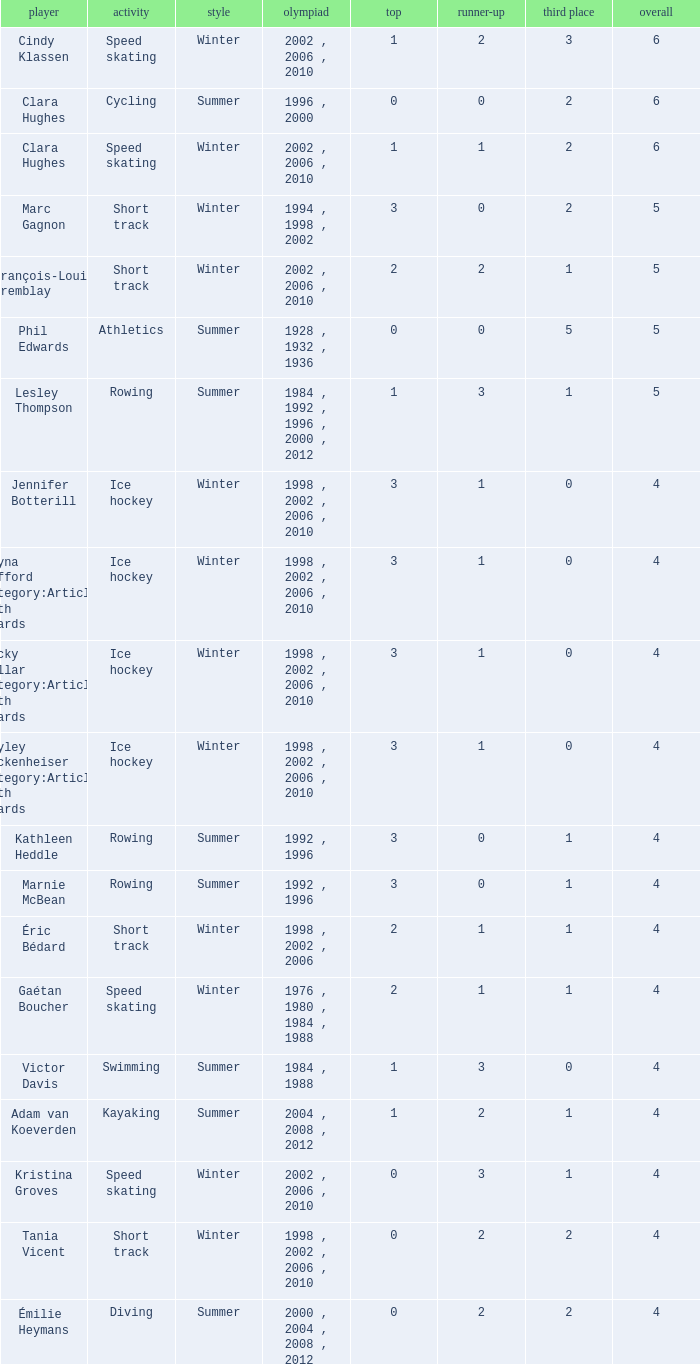What is the average gold of the winter athlete with 1 bronze, less than 3 silver, and less than 4 total medals? None. 